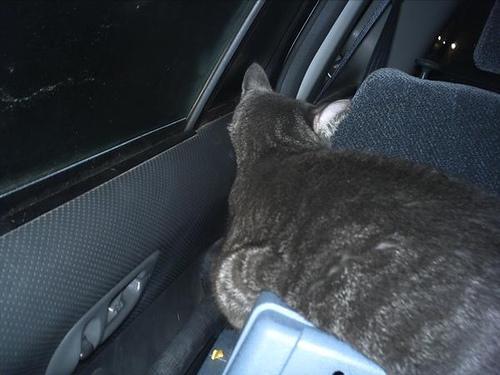How many cats are there?
Give a very brief answer. 1. How many people are holding children?
Give a very brief answer. 0. 